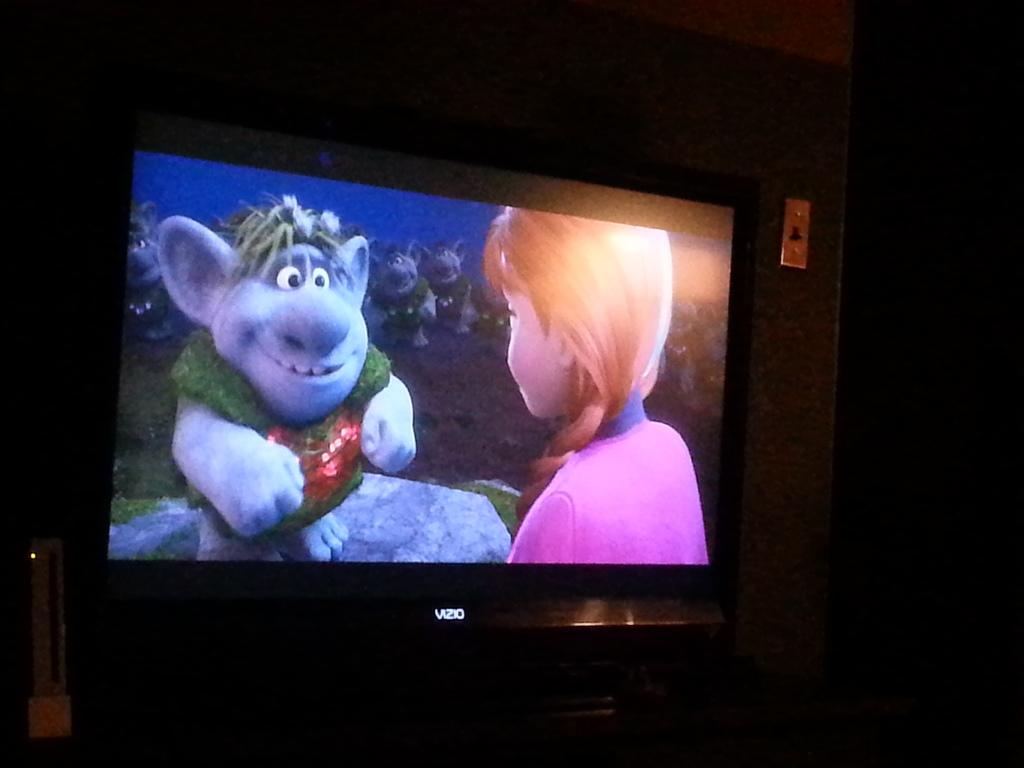Is the television company from vizio?
Your answer should be compact. Yes. 